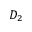Convert formula to latex. <formula><loc_0><loc_0><loc_500><loc_500>D _ { 2 }</formula> 